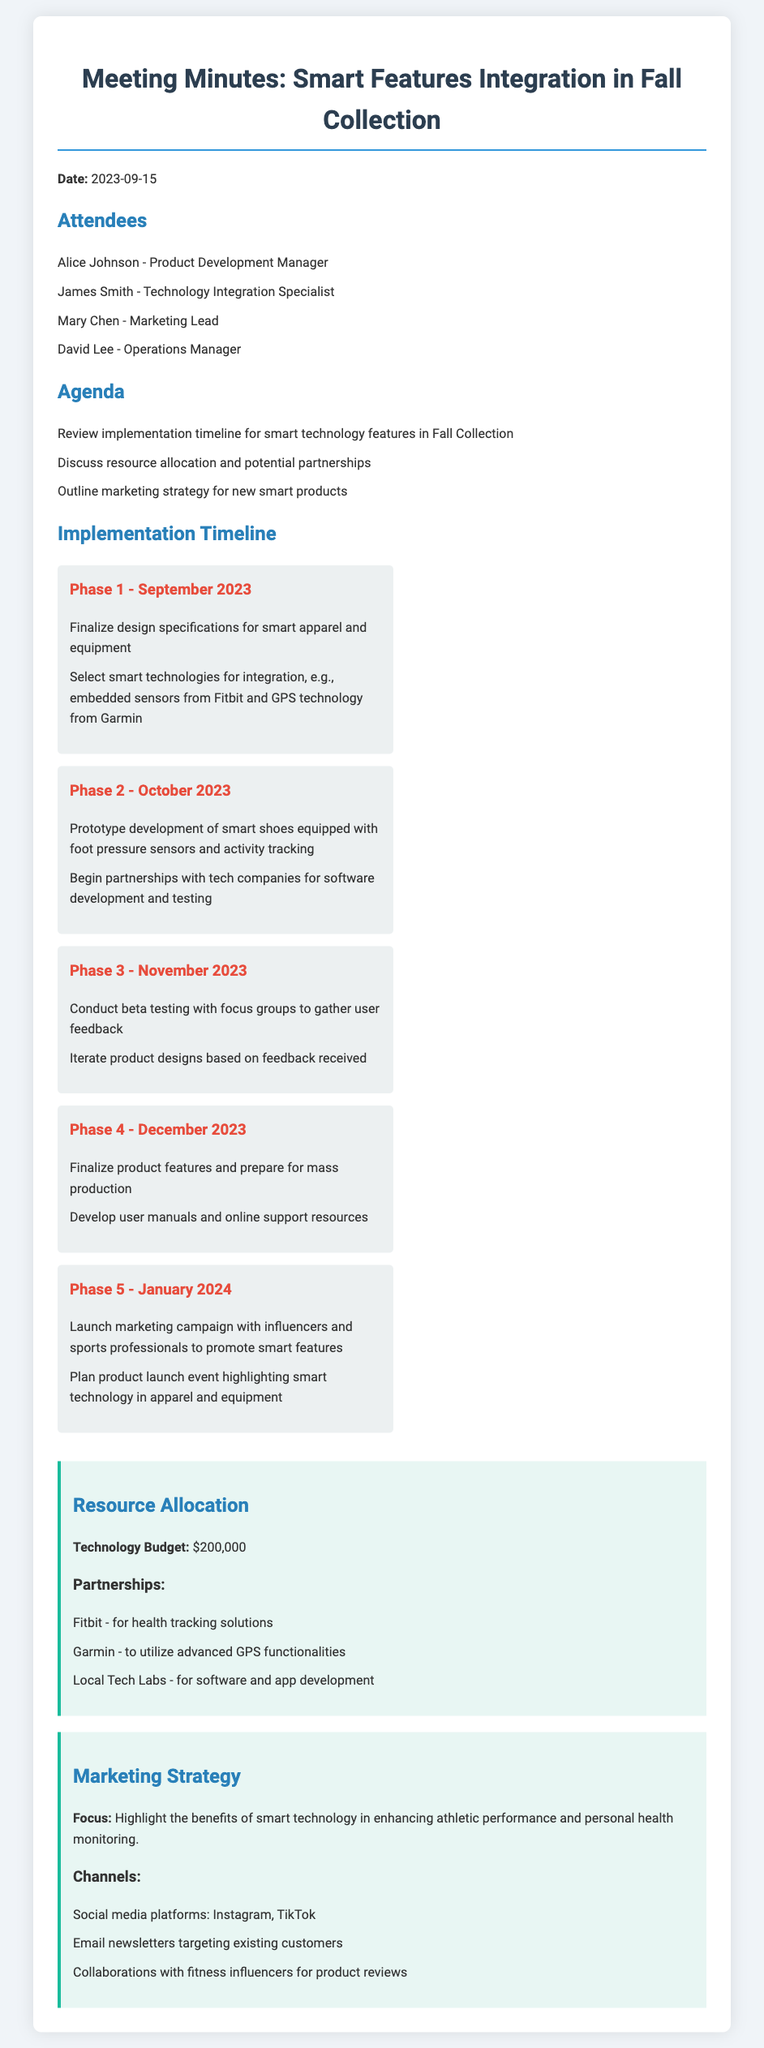What is the date of the meeting? The date of the meeting is explicitly mentioned at the start of the document.
Answer: 2023-09-15 Who is the Technology Integration Specialist? The document lists the attendees, including their roles, where this person's name is included.
Answer: James Smith What is the budget allocated for technology? The document states a specific figure for the technology budget in the section about resource allocation.
Answer: $200,000 What technology will be used for health tracking solutions? The resource allocation section specifies the partner company responsible for health tracking technology.
Answer: Fitbit What is the focus of the marketing strategy? The document outlines a specific focus regarding the benefits of smart technology which is listed under the marketing strategy.
Answer: Enhance athletic performance and personal health monitoring How many phases are there in the implementation timeline? The document lists the different phases of the implementation timeline, indicating the number of phases discussed.
Answer: 5 What is the main purpose of Phase 3 in the implementation timeline? The description of Phase 3 includes specific activities that define its primary objective within the timeline.
Answer: Conduct beta testing When will the product launch event be planned? The timeline specifically states an event associated with launching the product in a particular phase.
Answer: January 2024 